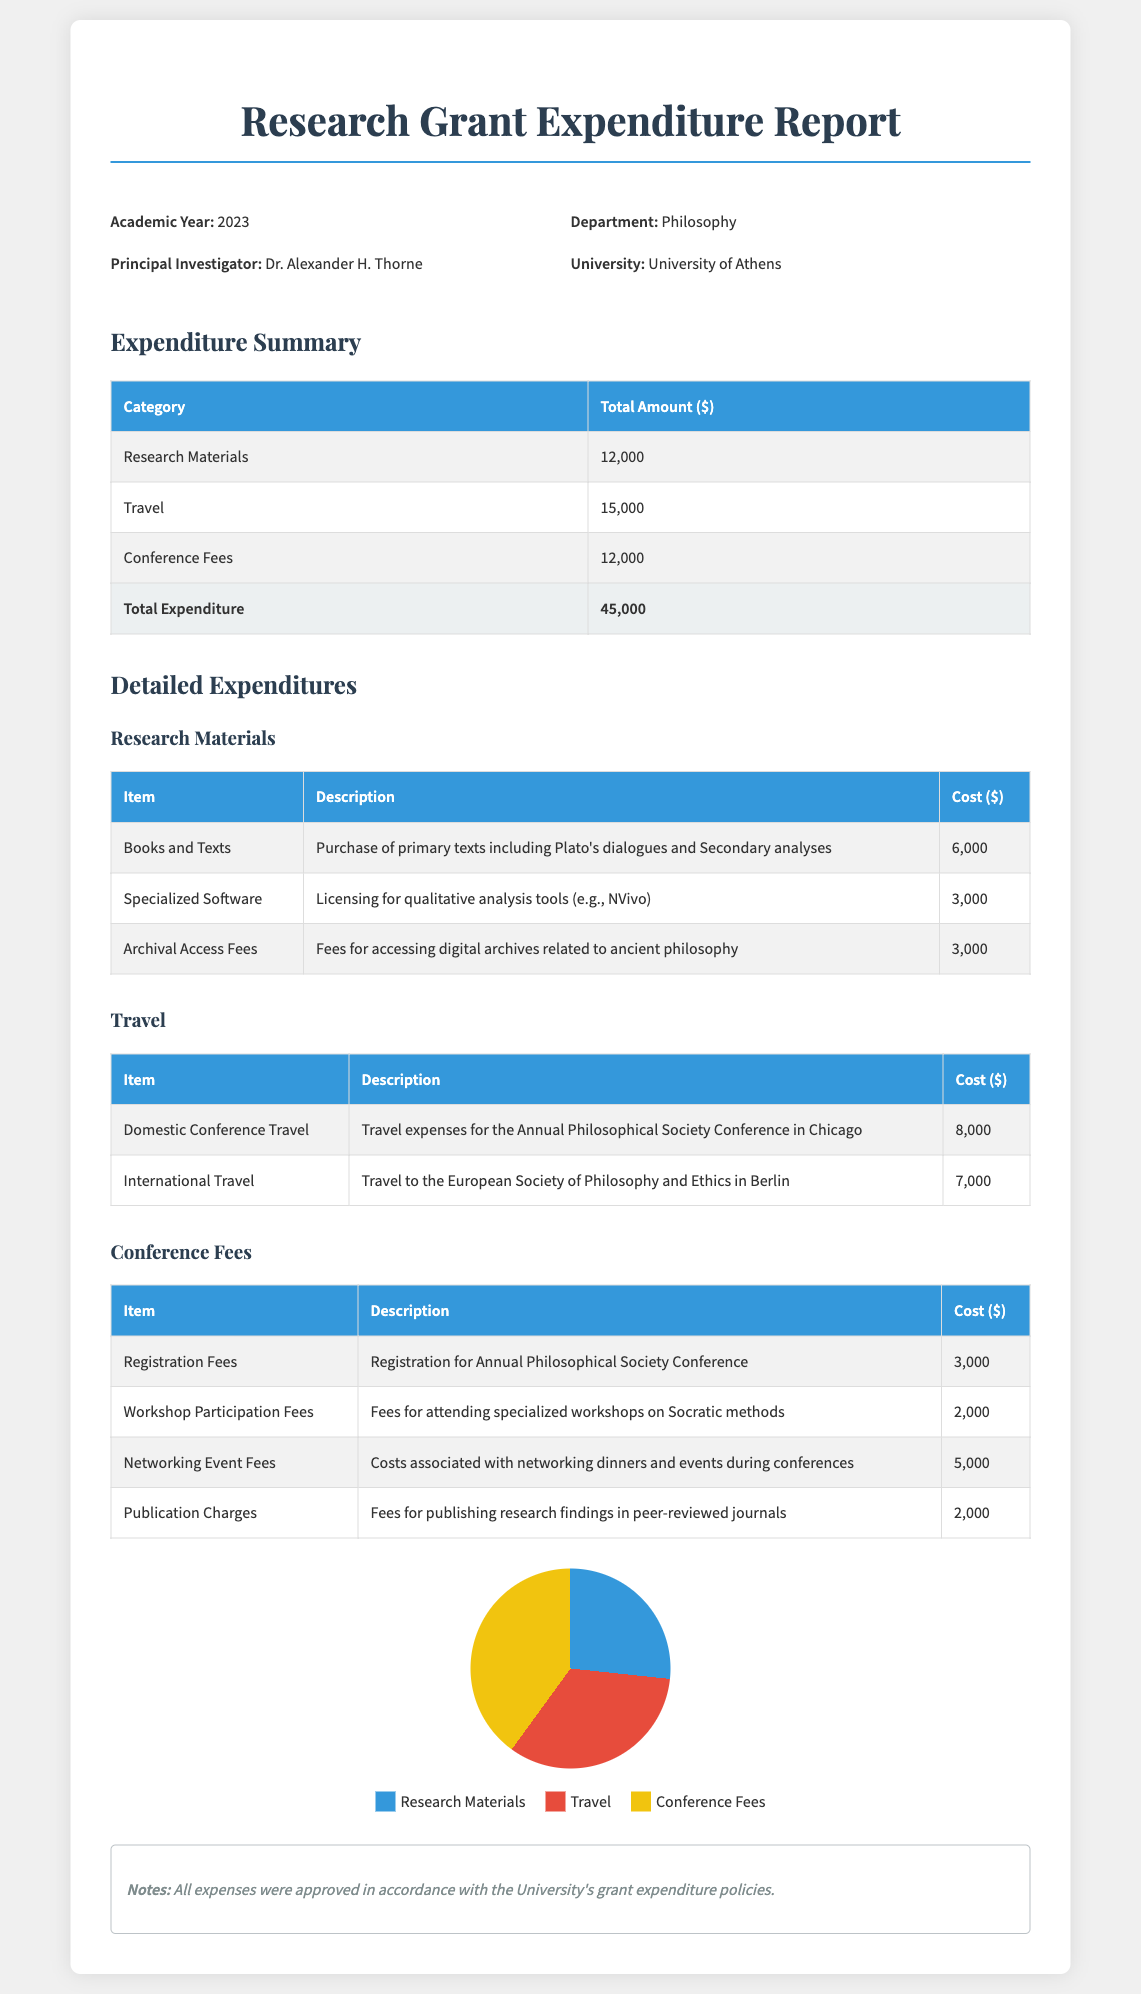What is the total amount spent on travel? The total amount spent on travel is explicitly stated in the summary section of the report.
Answer: 15,000 Who is the Principal Investigator? The Principal Investigator is listed directly under the header information of the report.
Answer: Dr. Alexander H. Thorne What was the cost of Publication Charges? The cost of Publication Charges can be found in the detailed expenditures for Conference Fees.
Answer: 2,000 What category had the highest expenditure? By comparing the total amounts in the expenditure summary, the category with the highest spending can be identified.
Answer: Travel How much was spent on Archival Access Fees? The amount spent on Archival Access Fees is noted in the detailed expenditures for Research Materials.
Answer: 3,000 What percentage of the total expenditure is attributed to Research Materials? The percentage can be calculated by taking the expenditure on Research Materials divided by the total expenditure, then multiplying by 100.
Answer: 26.67 What is the total expenditure for the Research Grant? The total expenditure is summarized in the report, combining all categories.
Answer: 45,000 How many items are listed under Travel expenses? The number of items listed can be counted from the detailed expenditures table under Travel.
Answer: 2 What fees were included for Networking Events? The fees for Networking Events can be found in the detailed table for Conference Fees.
Answer: 5,000 What kind of software was purchased? The type of software purchased is described in the detailed expenditures under Research Materials.
Answer: Specialized Software 